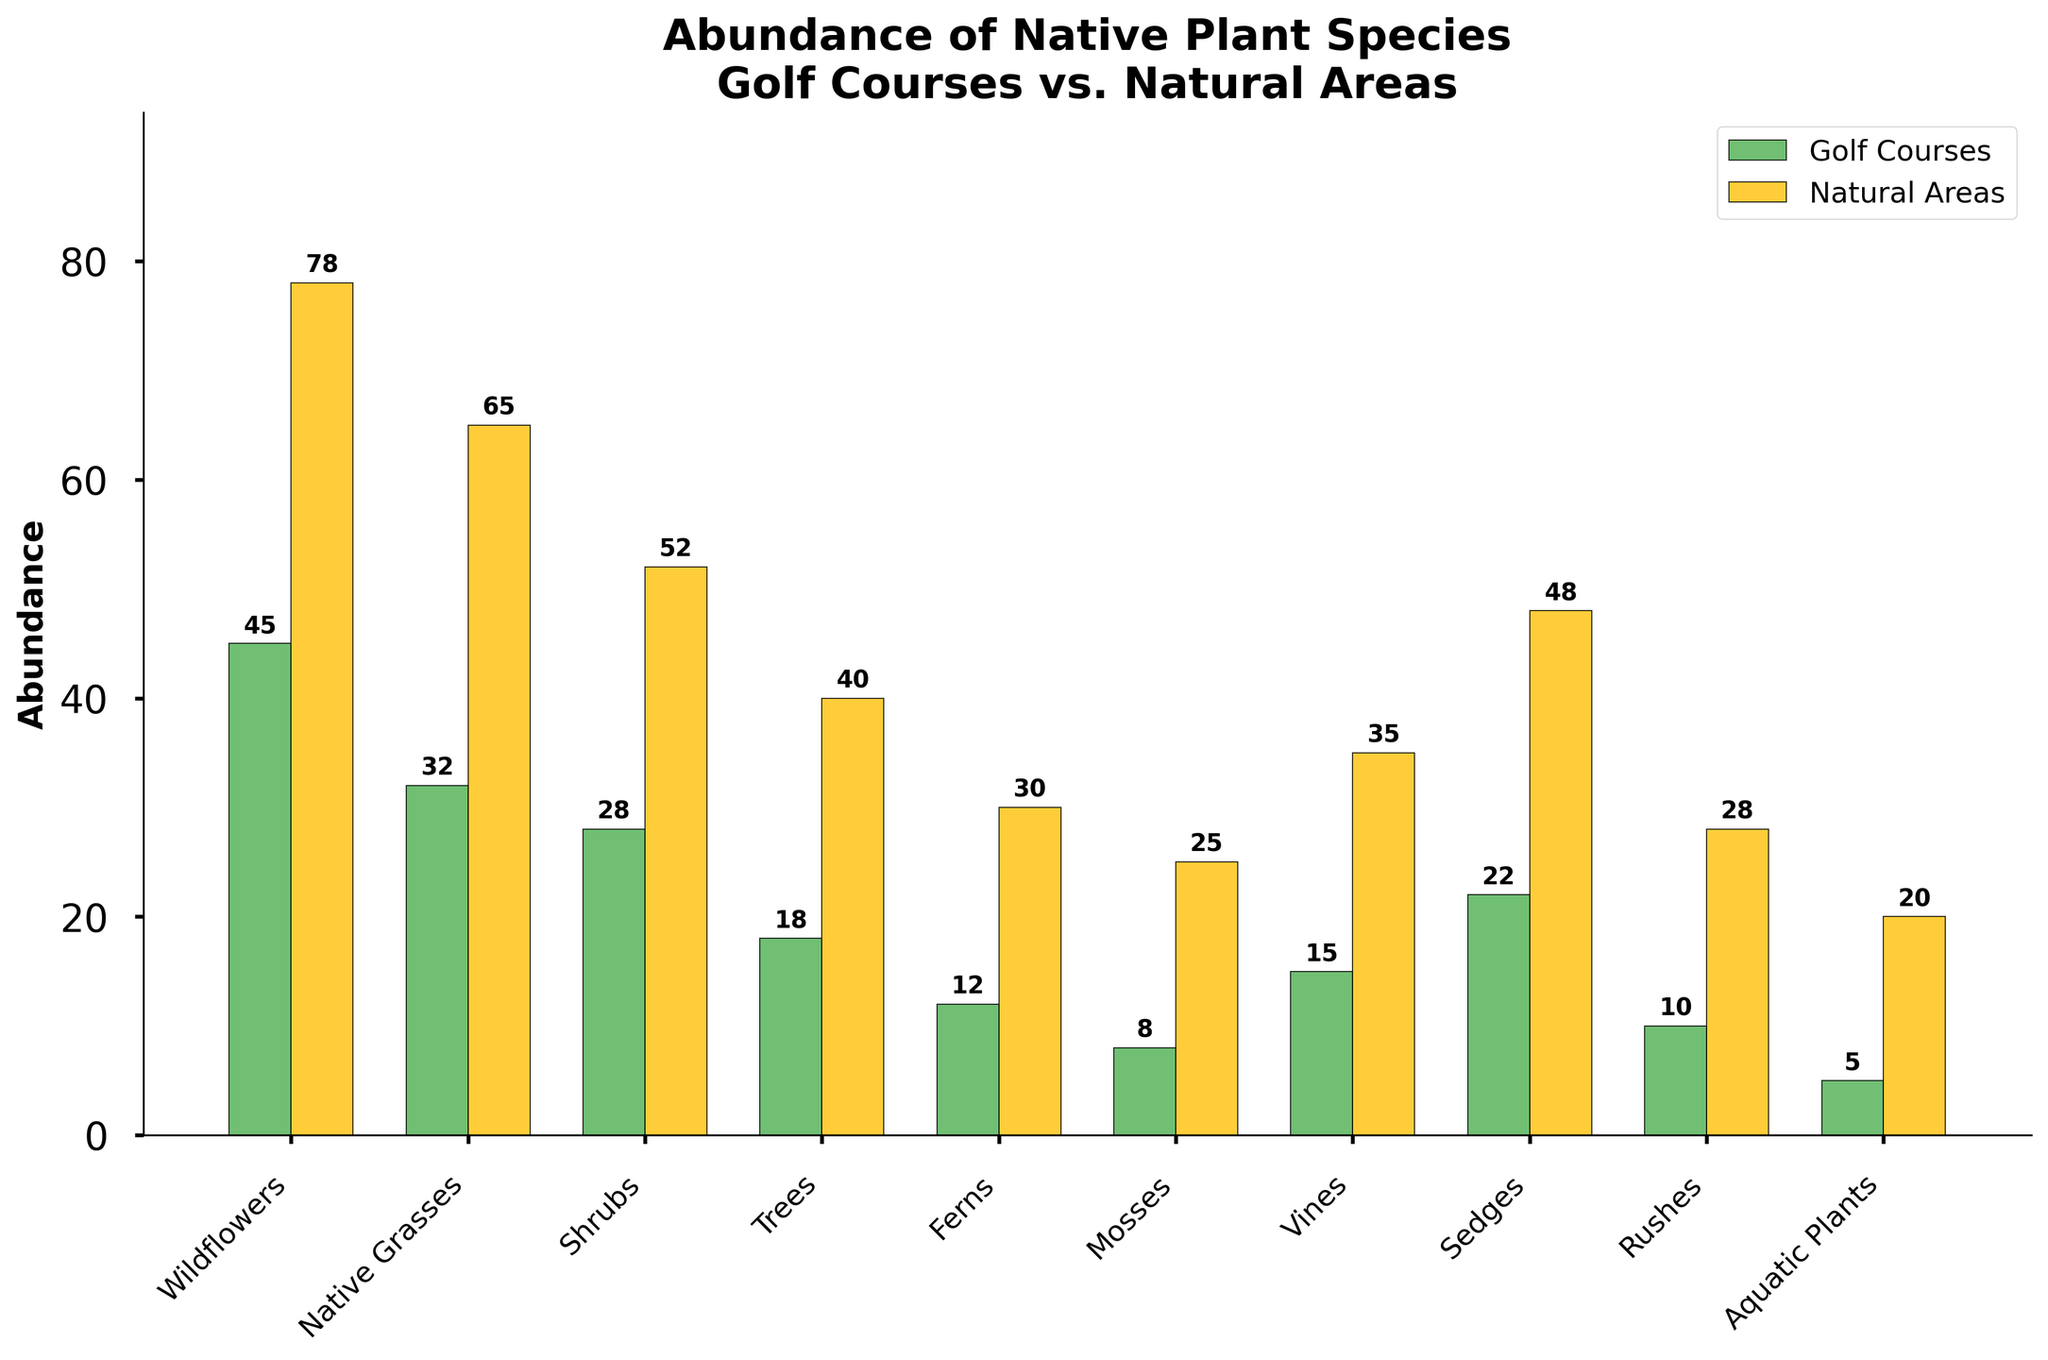Which plant type has the highest abundance in natural areas? By looking at the bars labeled 'Natural Areas,' we can see that the 'Wildflowers' bar is the tallest among all the plant types. Hence, 'Wildflowers' have the highest abundance.
Answer: Wildflowers Which plant type shows the smallest difference in abundance between golf courses and natural areas? Calculate the difference in abundance for each plant type: Wildflowers (33), Native Grasses (33), Shrubs (24), Trees (22), Ferns (18), Mosses (17), Vines (20), Sedges (26), Rushes (18), Aquatic Plants (15). The smallest difference is for 'Aquatic Plants'.
Answer: Aquatic Plants Are there any plant types that have the same abundance in both golf courses and natural areas? By inspecting the bars for each plant type, there are no plant types where the bars are of the same height in both golf courses and natural areas.
Answer: No Which plant type has the largest abundance in golf courses? By looking at the bars labeled 'Golf Courses,' the 'Wildflowers' bar is the tallest, which means 'Wildflowers' have the largest abundance in golf courses.
Answer: Wildflowers What is the total abundance of shrubs in both golf courses and natural areas? Add the abundances of shrubs in golf courses (28) and natural areas (52) to get the total. 28 + 52 = 80.
Answer: 80 How much lower is the abundance of native grasses on golf courses compared to natural areas? Subtract the abundance of native grasses on golf courses (32) from its abundance in natural areas (65). 65 - 32 = 33.
Answer: 33 Which plant type shows the smallest abundance in natural areas? By looking at the bars labeled 'Natural Areas,' the shortest bar is for 'Aquatic Plants,' indicating the smallest abundance.
Answer: Aquatic Plants How does the abundance of vines compare between golf courses and natural areas? Compare the heights of the bars for vines, showing 15 in golf courses and 35 in natural areas. 'Vines' have a higher abundance in natural areas than in golf courses.
Answer: Higher in natural areas What is the average abundance of ferns across both golf courses and natural areas? Add the abundance of ferns in golf courses (12) and natural areas (30), then divide by 2. Average = (12 + 30) / 2 = 21.
Answer: 21 Which plant type has a greater abundance on golf courses compared to rushes in natural areas? Compare the abundance of plant types in golf courses with the abundance of rushes in natural areas (28). Only the abundance of 'Wildflowers' (45) on golf courses is greater than rushes in natural areas.
Answer: Wildflowers 